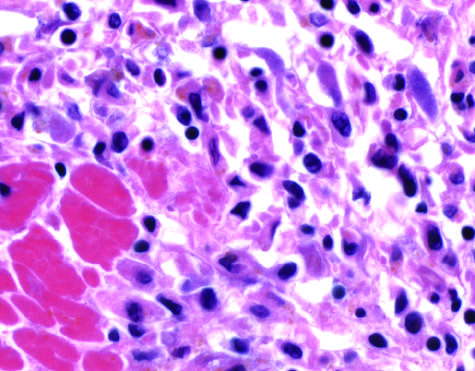when do the photomicrographs show an inflammatory reaction in the myocardium after ischemic necrosis infarction?
Answer the question using a single word or phrase. After ischemic necrosis infarction 